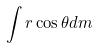<formula> <loc_0><loc_0><loc_500><loc_500>\int r \cos \theta d m</formula> 